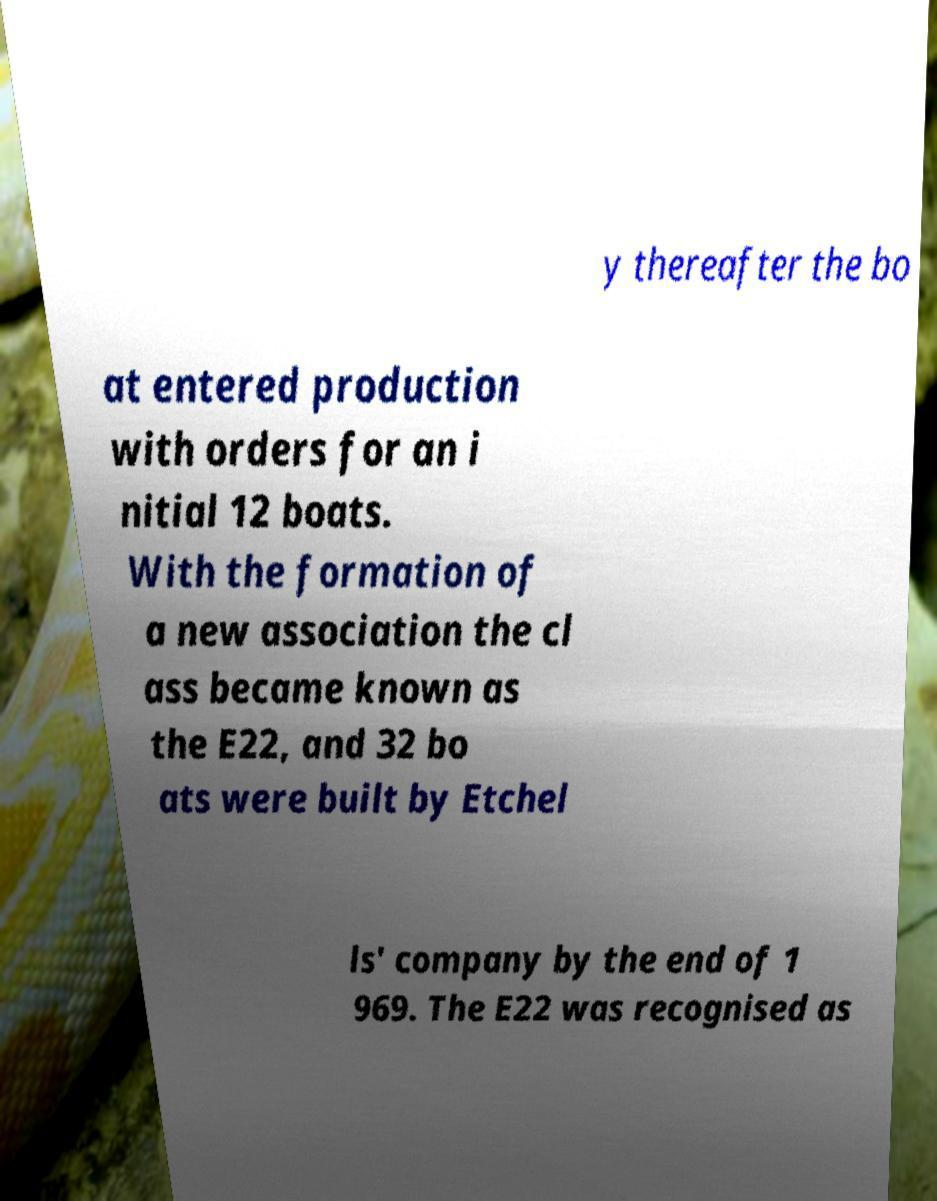For documentation purposes, I need the text within this image transcribed. Could you provide that? y thereafter the bo at entered production with orders for an i nitial 12 boats. With the formation of a new association the cl ass became known as the E22, and 32 bo ats were built by Etchel ls' company by the end of 1 969. The E22 was recognised as 